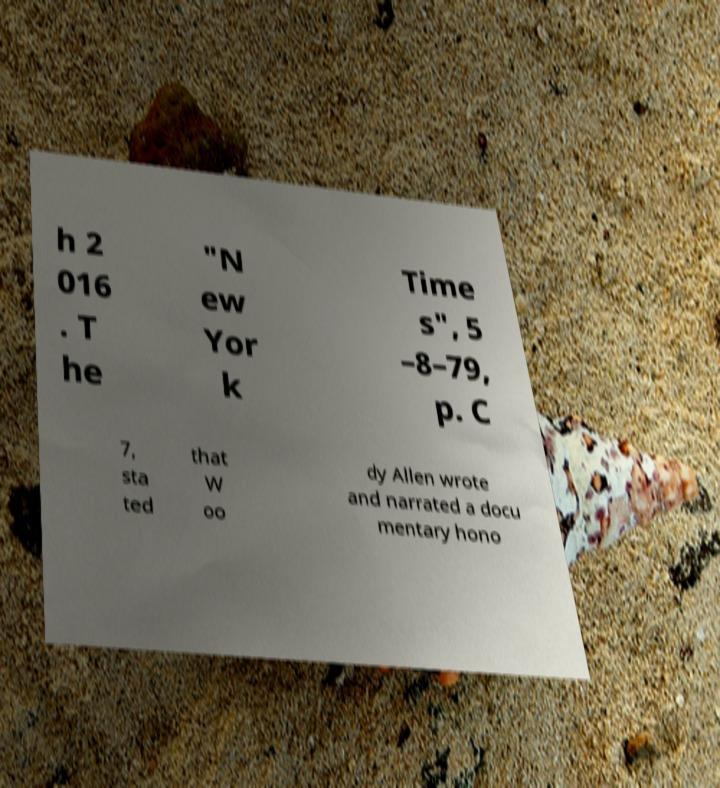Please read and relay the text visible in this image. What does it say? h 2 016 . T he "N ew Yor k Time s", 5 –8–79, p. C 7, sta ted that W oo dy Allen wrote and narrated a docu mentary hono 